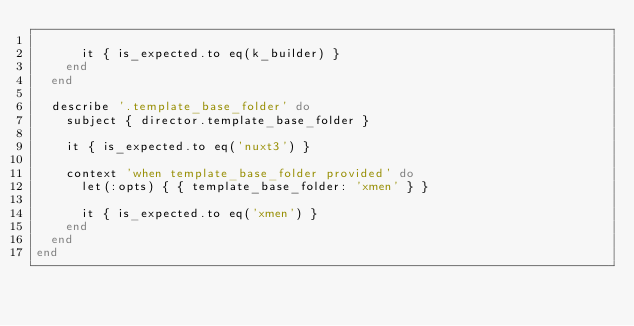Convert code to text. <code><loc_0><loc_0><loc_500><loc_500><_Ruby_>
      it { is_expected.to eq(k_builder) }
    end
  end

  describe '.template_base_folder' do
    subject { director.template_base_folder }

    it { is_expected.to eq('nuxt3') }

    context 'when template_base_folder provided' do
      let(:opts) { { template_base_folder: 'xmen' } }

      it { is_expected.to eq('xmen') }
    end
  end
end
</code> 